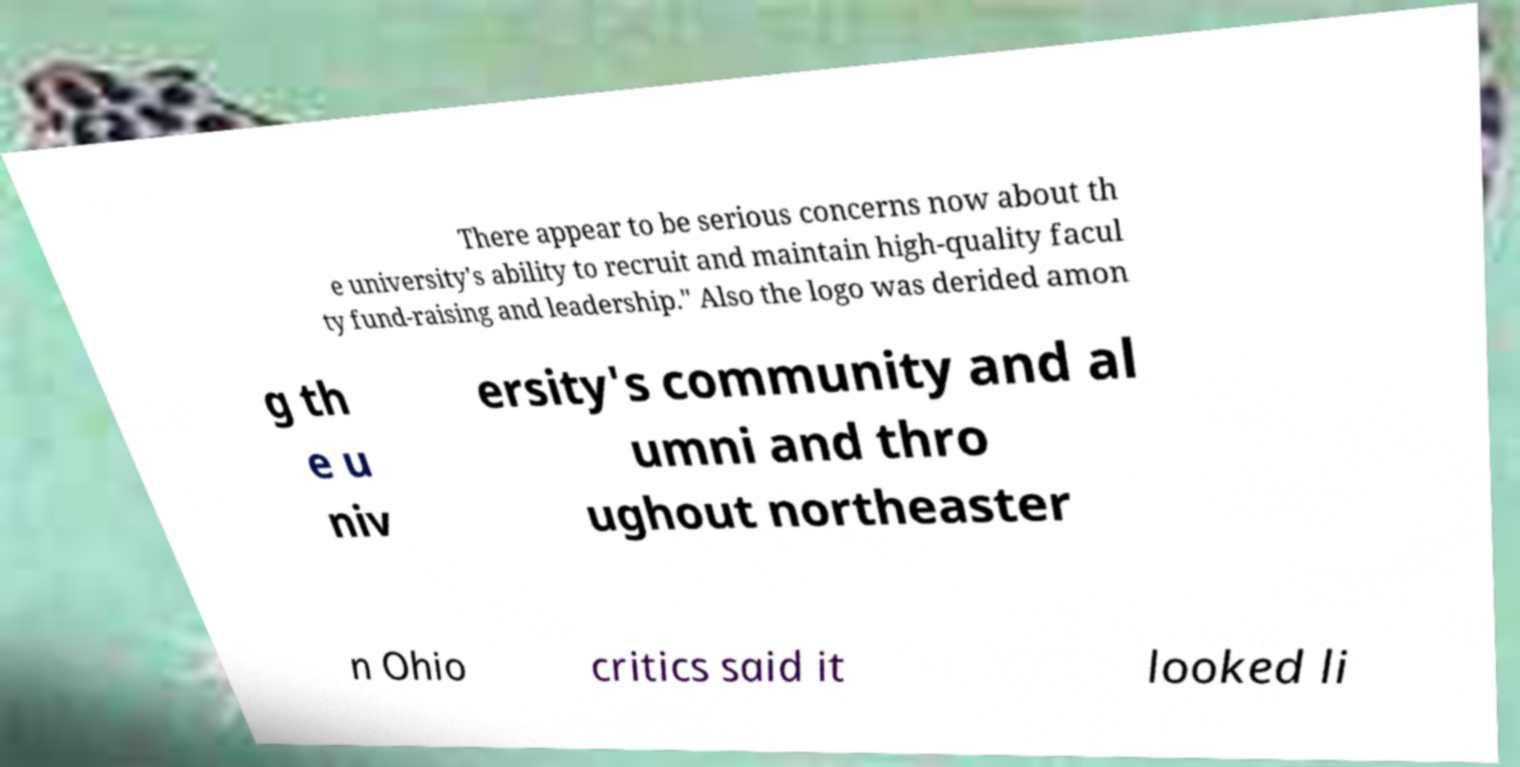Could you extract and type out the text from this image? There appear to be serious concerns now about th e university's ability to recruit and maintain high-quality facul ty fund-raising and leadership." Also the logo was derided amon g th e u niv ersity's community and al umni and thro ughout northeaster n Ohio critics said it looked li 